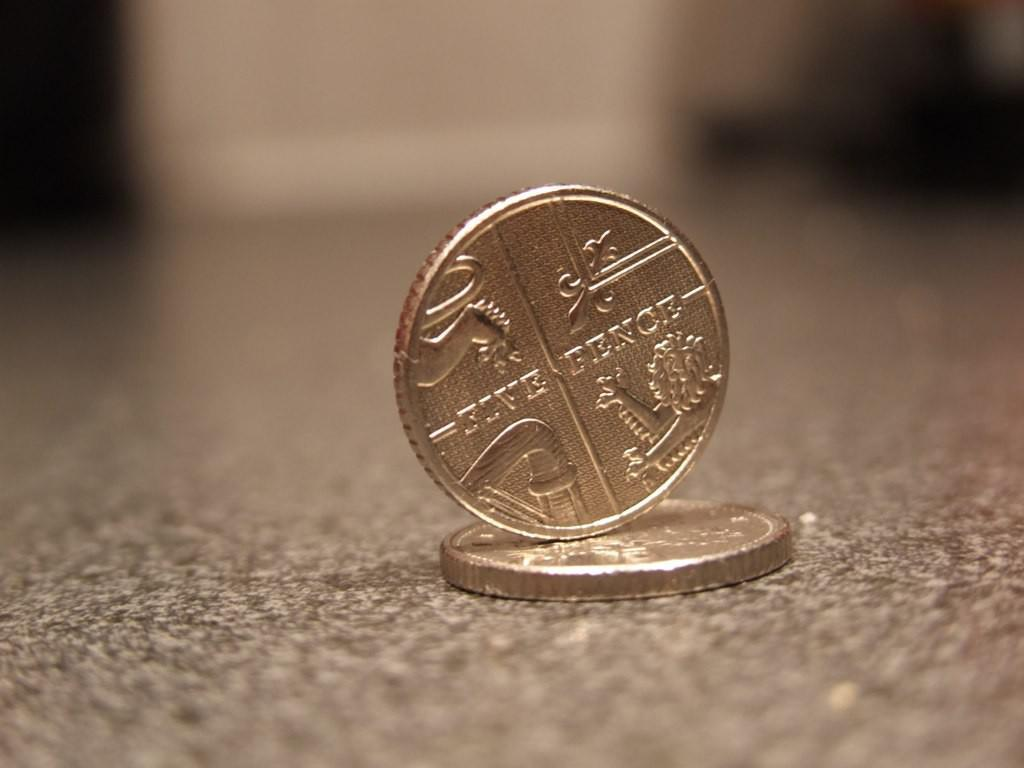<image>
Give a short and clear explanation of the subsequent image. A five pence coin balancing on another coin 